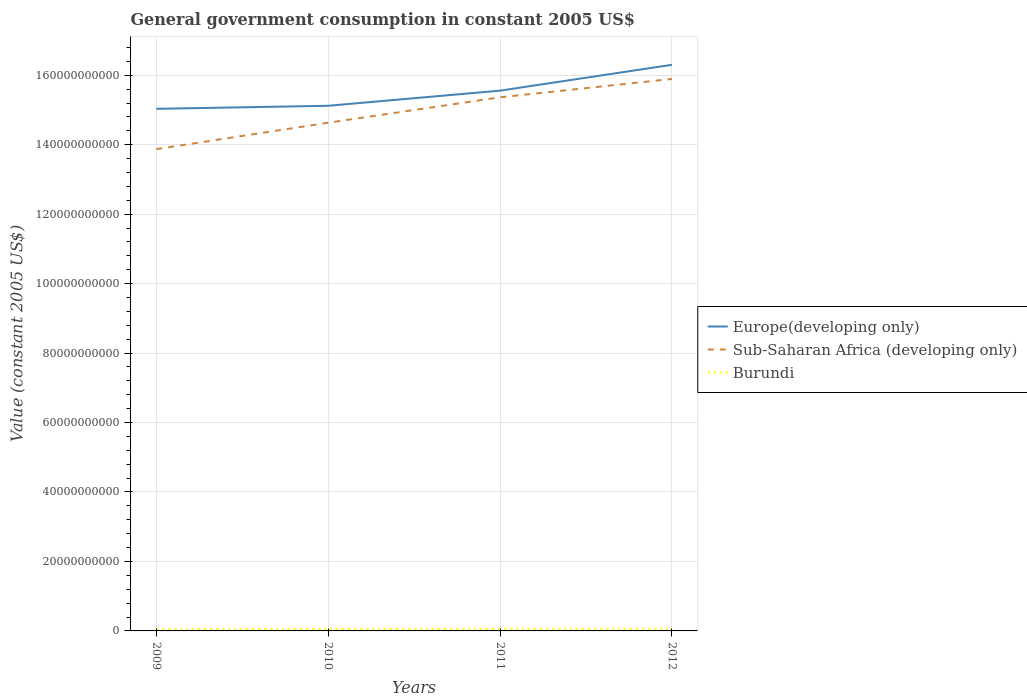How many different coloured lines are there?
Make the answer very short. 3. Across all years, what is the maximum government conusmption in Europe(developing only)?
Give a very brief answer. 1.50e+11. In which year was the government conusmption in Sub-Saharan Africa (developing only) maximum?
Give a very brief answer. 2009. What is the total government conusmption in Europe(developing only) in the graph?
Ensure brevity in your answer.  -5.23e+09. What is the difference between the highest and the second highest government conusmption in Burundi?
Provide a short and direct response. 1.48e+08. Is the government conusmption in Europe(developing only) strictly greater than the government conusmption in Sub-Saharan Africa (developing only) over the years?
Offer a terse response. No. Does the graph contain any zero values?
Offer a very short reply. No. How many legend labels are there?
Your answer should be compact. 3. What is the title of the graph?
Your answer should be compact. General government consumption in constant 2005 US$. What is the label or title of the Y-axis?
Your answer should be very brief. Value (constant 2005 US$). What is the Value (constant 2005 US$) of Europe(developing only) in 2009?
Provide a succinct answer. 1.50e+11. What is the Value (constant 2005 US$) in Sub-Saharan Africa (developing only) in 2009?
Make the answer very short. 1.39e+11. What is the Value (constant 2005 US$) of Burundi in 2009?
Make the answer very short. 4.75e+08. What is the Value (constant 2005 US$) of Europe(developing only) in 2010?
Offer a terse response. 1.51e+11. What is the Value (constant 2005 US$) in Sub-Saharan Africa (developing only) in 2010?
Offer a terse response. 1.46e+11. What is the Value (constant 2005 US$) in Burundi in 2010?
Provide a succinct answer. 5.97e+08. What is the Value (constant 2005 US$) of Europe(developing only) in 2011?
Keep it short and to the point. 1.56e+11. What is the Value (constant 2005 US$) of Sub-Saharan Africa (developing only) in 2011?
Your response must be concise. 1.54e+11. What is the Value (constant 2005 US$) in Burundi in 2011?
Give a very brief answer. 6.10e+08. What is the Value (constant 2005 US$) of Europe(developing only) in 2012?
Your answer should be compact. 1.63e+11. What is the Value (constant 2005 US$) in Sub-Saharan Africa (developing only) in 2012?
Your answer should be very brief. 1.59e+11. What is the Value (constant 2005 US$) in Burundi in 2012?
Make the answer very short. 6.23e+08. Across all years, what is the maximum Value (constant 2005 US$) of Europe(developing only)?
Your response must be concise. 1.63e+11. Across all years, what is the maximum Value (constant 2005 US$) of Sub-Saharan Africa (developing only)?
Keep it short and to the point. 1.59e+11. Across all years, what is the maximum Value (constant 2005 US$) of Burundi?
Your response must be concise. 6.23e+08. Across all years, what is the minimum Value (constant 2005 US$) of Europe(developing only)?
Ensure brevity in your answer.  1.50e+11. Across all years, what is the minimum Value (constant 2005 US$) of Sub-Saharan Africa (developing only)?
Ensure brevity in your answer.  1.39e+11. Across all years, what is the minimum Value (constant 2005 US$) in Burundi?
Make the answer very short. 4.75e+08. What is the total Value (constant 2005 US$) of Europe(developing only) in the graph?
Offer a very short reply. 6.20e+11. What is the total Value (constant 2005 US$) in Sub-Saharan Africa (developing only) in the graph?
Your response must be concise. 5.98e+11. What is the total Value (constant 2005 US$) of Burundi in the graph?
Your answer should be compact. 2.30e+09. What is the difference between the Value (constant 2005 US$) in Europe(developing only) in 2009 and that in 2010?
Make the answer very short. -8.73e+08. What is the difference between the Value (constant 2005 US$) in Sub-Saharan Africa (developing only) in 2009 and that in 2010?
Provide a succinct answer. -7.61e+09. What is the difference between the Value (constant 2005 US$) of Burundi in 2009 and that in 2010?
Your answer should be very brief. -1.22e+08. What is the difference between the Value (constant 2005 US$) of Europe(developing only) in 2009 and that in 2011?
Your answer should be compact. -5.23e+09. What is the difference between the Value (constant 2005 US$) of Sub-Saharan Africa (developing only) in 2009 and that in 2011?
Ensure brevity in your answer.  -1.49e+1. What is the difference between the Value (constant 2005 US$) of Burundi in 2009 and that in 2011?
Give a very brief answer. -1.36e+08. What is the difference between the Value (constant 2005 US$) in Europe(developing only) in 2009 and that in 2012?
Provide a short and direct response. -1.27e+1. What is the difference between the Value (constant 2005 US$) of Sub-Saharan Africa (developing only) in 2009 and that in 2012?
Offer a very short reply. -2.02e+1. What is the difference between the Value (constant 2005 US$) of Burundi in 2009 and that in 2012?
Keep it short and to the point. -1.48e+08. What is the difference between the Value (constant 2005 US$) in Europe(developing only) in 2010 and that in 2011?
Your response must be concise. -4.36e+09. What is the difference between the Value (constant 2005 US$) in Sub-Saharan Africa (developing only) in 2010 and that in 2011?
Keep it short and to the point. -7.32e+09. What is the difference between the Value (constant 2005 US$) of Burundi in 2010 and that in 2011?
Provide a short and direct response. -1.38e+07. What is the difference between the Value (constant 2005 US$) in Europe(developing only) in 2010 and that in 2012?
Make the answer very short. -1.18e+1. What is the difference between the Value (constant 2005 US$) in Sub-Saharan Africa (developing only) in 2010 and that in 2012?
Your response must be concise. -1.26e+1. What is the difference between the Value (constant 2005 US$) in Burundi in 2010 and that in 2012?
Your answer should be very brief. -2.60e+07. What is the difference between the Value (constant 2005 US$) of Europe(developing only) in 2011 and that in 2012?
Offer a very short reply. -7.44e+09. What is the difference between the Value (constant 2005 US$) in Sub-Saharan Africa (developing only) in 2011 and that in 2012?
Offer a very short reply. -5.28e+09. What is the difference between the Value (constant 2005 US$) in Burundi in 2011 and that in 2012?
Give a very brief answer. -1.22e+07. What is the difference between the Value (constant 2005 US$) of Europe(developing only) in 2009 and the Value (constant 2005 US$) of Sub-Saharan Africa (developing only) in 2010?
Offer a very short reply. 4.00e+09. What is the difference between the Value (constant 2005 US$) of Europe(developing only) in 2009 and the Value (constant 2005 US$) of Burundi in 2010?
Your answer should be very brief. 1.50e+11. What is the difference between the Value (constant 2005 US$) of Sub-Saharan Africa (developing only) in 2009 and the Value (constant 2005 US$) of Burundi in 2010?
Your answer should be very brief. 1.38e+11. What is the difference between the Value (constant 2005 US$) in Europe(developing only) in 2009 and the Value (constant 2005 US$) in Sub-Saharan Africa (developing only) in 2011?
Your answer should be very brief. -3.32e+09. What is the difference between the Value (constant 2005 US$) in Europe(developing only) in 2009 and the Value (constant 2005 US$) in Burundi in 2011?
Make the answer very short. 1.50e+11. What is the difference between the Value (constant 2005 US$) in Sub-Saharan Africa (developing only) in 2009 and the Value (constant 2005 US$) in Burundi in 2011?
Provide a succinct answer. 1.38e+11. What is the difference between the Value (constant 2005 US$) in Europe(developing only) in 2009 and the Value (constant 2005 US$) in Sub-Saharan Africa (developing only) in 2012?
Offer a terse response. -8.59e+09. What is the difference between the Value (constant 2005 US$) of Europe(developing only) in 2009 and the Value (constant 2005 US$) of Burundi in 2012?
Offer a very short reply. 1.50e+11. What is the difference between the Value (constant 2005 US$) in Sub-Saharan Africa (developing only) in 2009 and the Value (constant 2005 US$) in Burundi in 2012?
Give a very brief answer. 1.38e+11. What is the difference between the Value (constant 2005 US$) in Europe(developing only) in 2010 and the Value (constant 2005 US$) in Sub-Saharan Africa (developing only) in 2011?
Provide a succinct answer. -2.44e+09. What is the difference between the Value (constant 2005 US$) of Europe(developing only) in 2010 and the Value (constant 2005 US$) of Burundi in 2011?
Ensure brevity in your answer.  1.51e+11. What is the difference between the Value (constant 2005 US$) of Sub-Saharan Africa (developing only) in 2010 and the Value (constant 2005 US$) of Burundi in 2011?
Ensure brevity in your answer.  1.46e+11. What is the difference between the Value (constant 2005 US$) in Europe(developing only) in 2010 and the Value (constant 2005 US$) in Sub-Saharan Africa (developing only) in 2012?
Your answer should be very brief. -7.72e+09. What is the difference between the Value (constant 2005 US$) of Europe(developing only) in 2010 and the Value (constant 2005 US$) of Burundi in 2012?
Make the answer very short. 1.51e+11. What is the difference between the Value (constant 2005 US$) in Sub-Saharan Africa (developing only) in 2010 and the Value (constant 2005 US$) in Burundi in 2012?
Give a very brief answer. 1.46e+11. What is the difference between the Value (constant 2005 US$) of Europe(developing only) in 2011 and the Value (constant 2005 US$) of Sub-Saharan Africa (developing only) in 2012?
Offer a very short reply. -3.36e+09. What is the difference between the Value (constant 2005 US$) in Europe(developing only) in 2011 and the Value (constant 2005 US$) in Burundi in 2012?
Ensure brevity in your answer.  1.55e+11. What is the difference between the Value (constant 2005 US$) in Sub-Saharan Africa (developing only) in 2011 and the Value (constant 2005 US$) in Burundi in 2012?
Provide a succinct answer. 1.53e+11. What is the average Value (constant 2005 US$) in Europe(developing only) per year?
Make the answer very short. 1.55e+11. What is the average Value (constant 2005 US$) of Sub-Saharan Africa (developing only) per year?
Offer a terse response. 1.49e+11. What is the average Value (constant 2005 US$) in Burundi per year?
Keep it short and to the point. 5.76e+08. In the year 2009, what is the difference between the Value (constant 2005 US$) in Europe(developing only) and Value (constant 2005 US$) in Sub-Saharan Africa (developing only)?
Your response must be concise. 1.16e+1. In the year 2009, what is the difference between the Value (constant 2005 US$) in Europe(developing only) and Value (constant 2005 US$) in Burundi?
Provide a short and direct response. 1.50e+11. In the year 2009, what is the difference between the Value (constant 2005 US$) in Sub-Saharan Africa (developing only) and Value (constant 2005 US$) in Burundi?
Your answer should be compact. 1.38e+11. In the year 2010, what is the difference between the Value (constant 2005 US$) of Europe(developing only) and Value (constant 2005 US$) of Sub-Saharan Africa (developing only)?
Ensure brevity in your answer.  4.88e+09. In the year 2010, what is the difference between the Value (constant 2005 US$) in Europe(developing only) and Value (constant 2005 US$) in Burundi?
Make the answer very short. 1.51e+11. In the year 2010, what is the difference between the Value (constant 2005 US$) in Sub-Saharan Africa (developing only) and Value (constant 2005 US$) in Burundi?
Your response must be concise. 1.46e+11. In the year 2011, what is the difference between the Value (constant 2005 US$) of Europe(developing only) and Value (constant 2005 US$) of Sub-Saharan Africa (developing only)?
Provide a succinct answer. 1.91e+09. In the year 2011, what is the difference between the Value (constant 2005 US$) in Europe(developing only) and Value (constant 2005 US$) in Burundi?
Provide a succinct answer. 1.55e+11. In the year 2011, what is the difference between the Value (constant 2005 US$) in Sub-Saharan Africa (developing only) and Value (constant 2005 US$) in Burundi?
Give a very brief answer. 1.53e+11. In the year 2012, what is the difference between the Value (constant 2005 US$) of Europe(developing only) and Value (constant 2005 US$) of Sub-Saharan Africa (developing only)?
Offer a terse response. 4.08e+09. In the year 2012, what is the difference between the Value (constant 2005 US$) in Europe(developing only) and Value (constant 2005 US$) in Burundi?
Offer a terse response. 1.62e+11. In the year 2012, what is the difference between the Value (constant 2005 US$) of Sub-Saharan Africa (developing only) and Value (constant 2005 US$) of Burundi?
Your response must be concise. 1.58e+11. What is the ratio of the Value (constant 2005 US$) in Europe(developing only) in 2009 to that in 2010?
Offer a very short reply. 0.99. What is the ratio of the Value (constant 2005 US$) in Sub-Saharan Africa (developing only) in 2009 to that in 2010?
Make the answer very short. 0.95. What is the ratio of the Value (constant 2005 US$) in Burundi in 2009 to that in 2010?
Your answer should be compact. 0.8. What is the ratio of the Value (constant 2005 US$) of Europe(developing only) in 2009 to that in 2011?
Ensure brevity in your answer.  0.97. What is the ratio of the Value (constant 2005 US$) in Sub-Saharan Africa (developing only) in 2009 to that in 2011?
Provide a short and direct response. 0.9. What is the ratio of the Value (constant 2005 US$) in Burundi in 2009 to that in 2011?
Make the answer very short. 0.78. What is the ratio of the Value (constant 2005 US$) of Europe(developing only) in 2009 to that in 2012?
Give a very brief answer. 0.92. What is the ratio of the Value (constant 2005 US$) of Sub-Saharan Africa (developing only) in 2009 to that in 2012?
Ensure brevity in your answer.  0.87. What is the ratio of the Value (constant 2005 US$) in Burundi in 2009 to that in 2012?
Ensure brevity in your answer.  0.76. What is the ratio of the Value (constant 2005 US$) of Europe(developing only) in 2010 to that in 2011?
Provide a short and direct response. 0.97. What is the ratio of the Value (constant 2005 US$) in Sub-Saharan Africa (developing only) in 2010 to that in 2011?
Give a very brief answer. 0.95. What is the ratio of the Value (constant 2005 US$) in Burundi in 2010 to that in 2011?
Give a very brief answer. 0.98. What is the ratio of the Value (constant 2005 US$) of Europe(developing only) in 2010 to that in 2012?
Make the answer very short. 0.93. What is the ratio of the Value (constant 2005 US$) in Sub-Saharan Africa (developing only) in 2010 to that in 2012?
Your answer should be very brief. 0.92. What is the ratio of the Value (constant 2005 US$) of Burundi in 2010 to that in 2012?
Provide a succinct answer. 0.96. What is the ratio of the Value (constant 2005 US$) in Europe(developing only) in 2011 to that in 2012?
Offer a very short reply. 0.95. What is the ratio of the Value (constant 2005 US$) in Sub-Saharan Africa (developing only) in 2011 to that in 2012?
Give a very brief answer. 0.97. What is the ratio of the Value (constant 2005 US$) in Burundi in 2011 to that in 2012?
Give a very brief answer. 0.98. What is the difference between the highest and the second highest Value (constant 2005 US$) of Europe(developing only)?
Keep it short and to the point. 7.44e+09. What is the difference between the highest and the second highest Value (constant 2005 US$) in Sub-Saharan Africa (developing only)?
Offer a very short reply. 5.28e+09. What is the difference between the highest and the second highest Value (constant 2005 US$) of Burundi?
Provide a succinct answer. 1.22e+07. What is the difference between the highest and the lowest Value (constant 2005 US$) of Europe(developing only)?
Provide a short and direct response. 1.27e+1. What is the difference between the highest and the lowest Value (constant 2005 US$) in Sub-Saharan Africa (developing only)?
Make the answer very short. 2.02e+1. What is the difference between the highest and the lowest Value (constant 2005 US$) in Burundi?
Make the answer very short. 1.48e+08. 